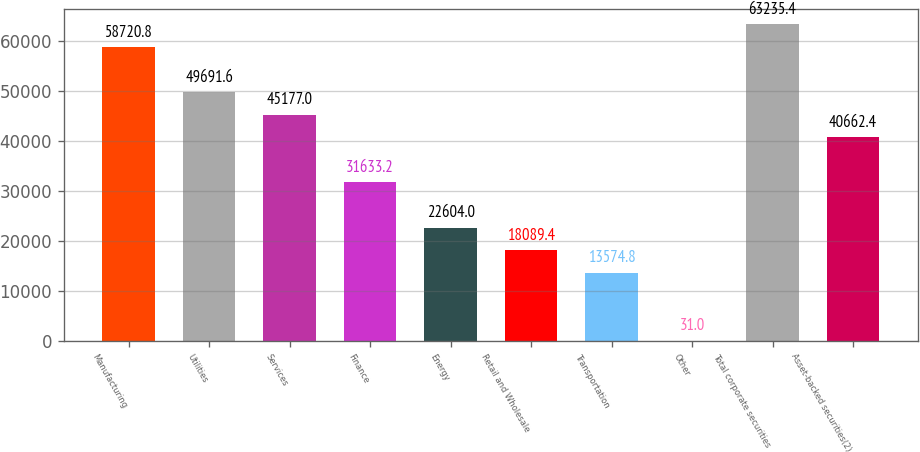Convert chart to OTSL. <chart><loc_0><loc_0><loc_500><loc_500><bar_chart><fcel>Manufacturing<fcel>Utilities<fcel>Services<fcel>Finance<fcel>Energy<fcel>Retail and Wholesale<fcel>Transportation<fcel>Other<fcel>Total corporate securities<fcel>Asset-backed securities(2)<nl><fcel>58720.8<fcel>49691.6<fcel>45177<fcel>31633.2<fcel>22604<fcel>18089.4<fcel>13574.8<fcel>31<fcel>63235.4<fcel>40662.4<nl></chart> 